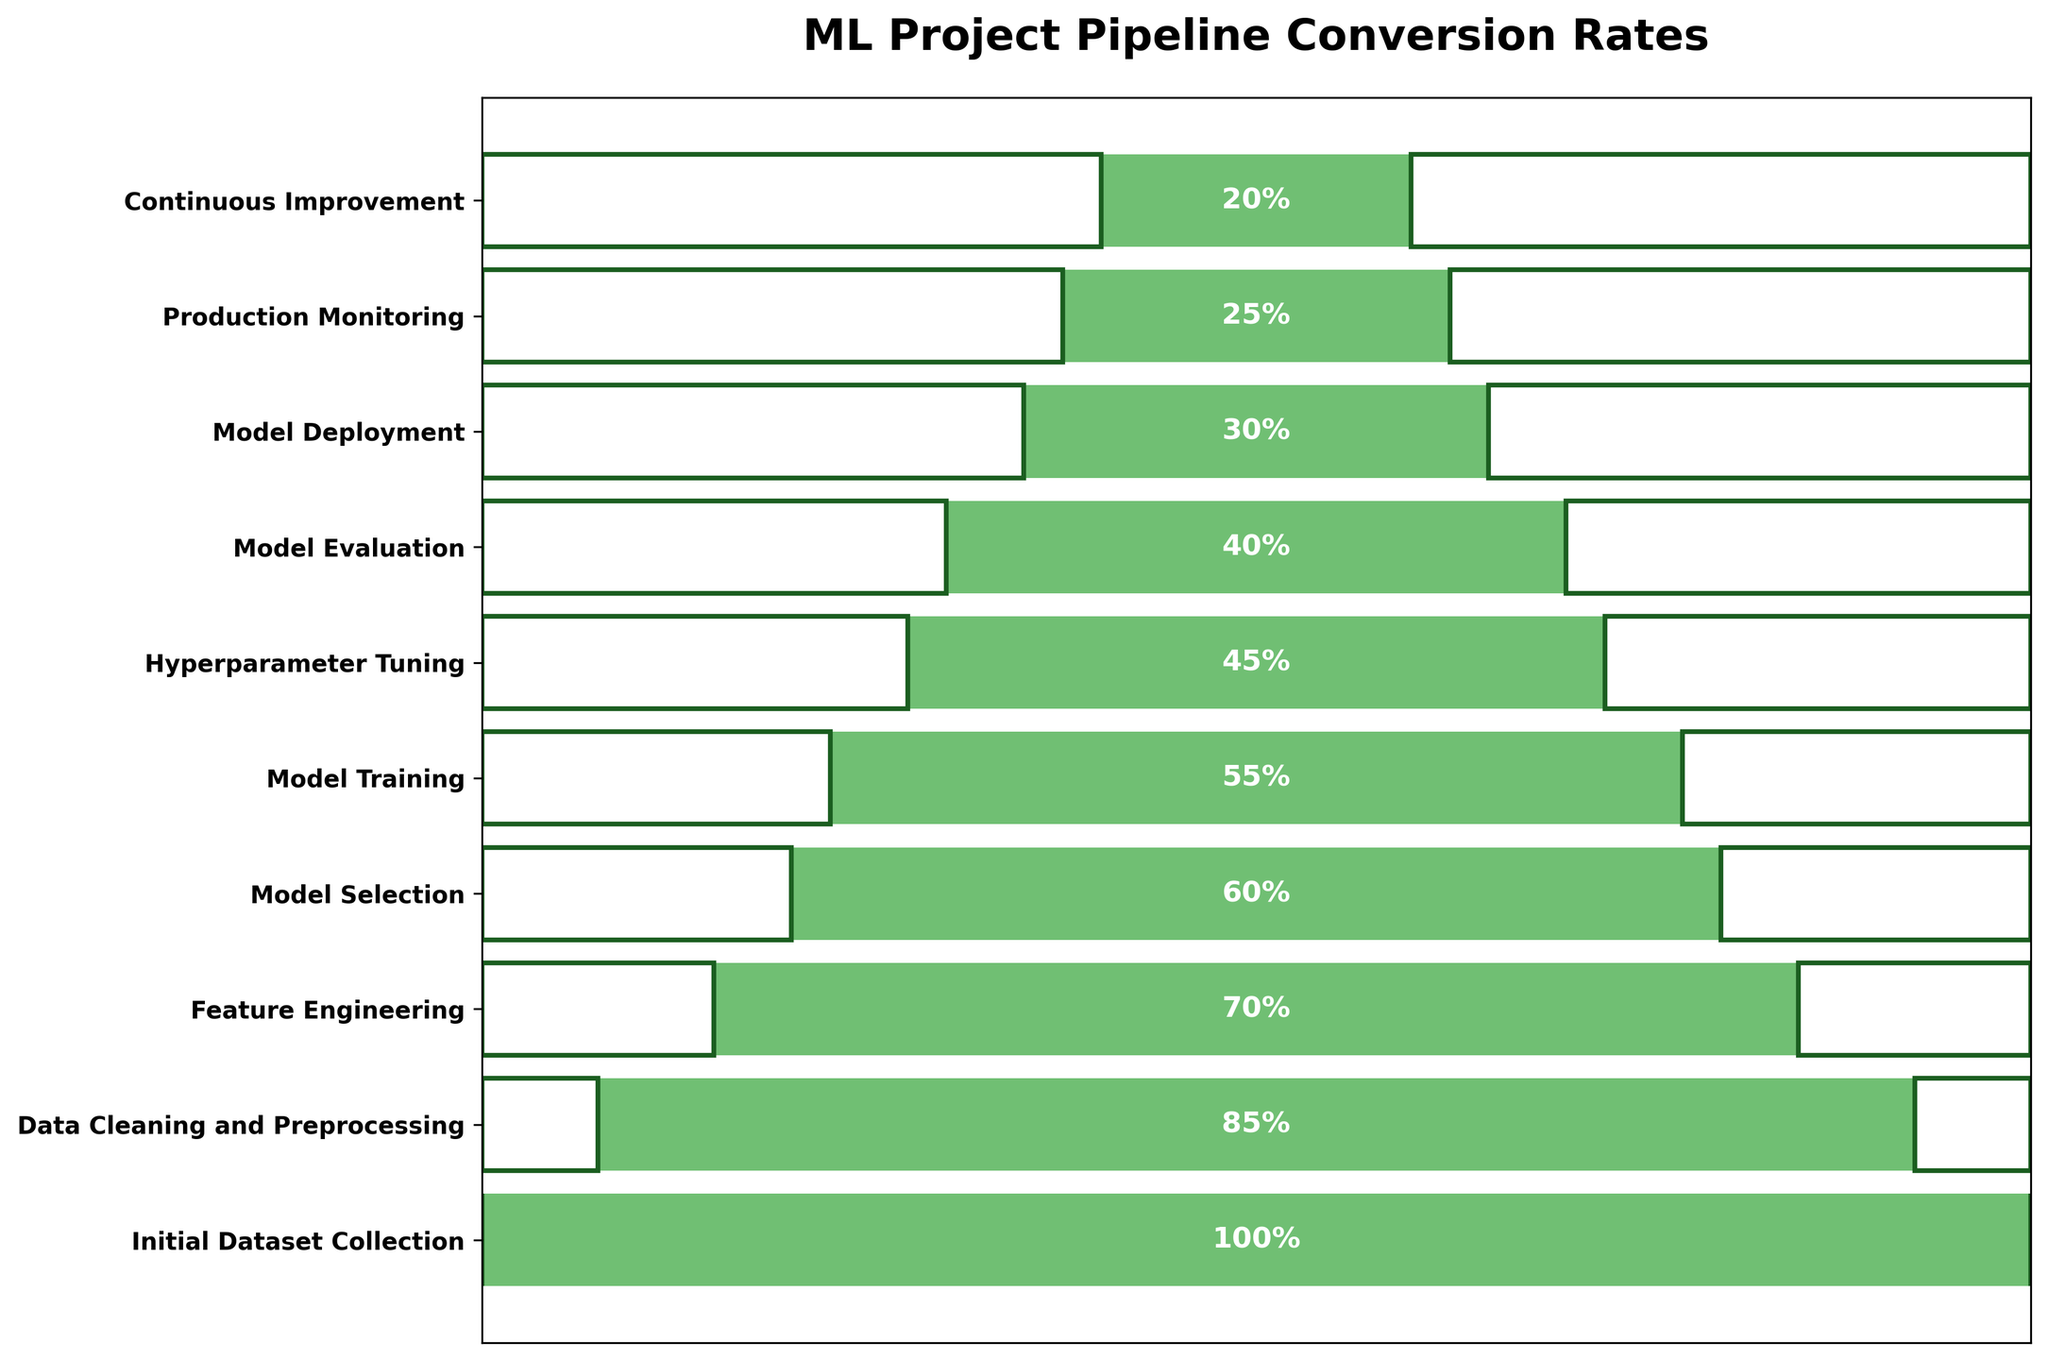What's the title of the funnel chart? The title is displayed at the top of the chart and summarizes what the chart represents.
Answer: ML Project Pipeline Conversion Rates How many stages are there in the pipeline? The number of horizontal bars (stages) represents the different stages in the pipeline. By counting these bars, we can determine there are 10 stages.
Answer: 10 Which stage has the highest conversion percentage? The highest conversion percentage corresponds to the longest bar, located at the top and representing the first stage.
Answer: Initial Dataset Collection What is the conversion rate difference between "Initial Dataset Collection" and "Production Monitoring"? We can find the difference by subtracting the conversion rates of both stages. Initial Dataset Collection is 100% and Production Monitoring is 25%. 100% - 25% = 75%
Answer: 75% How much greater is the conversion rate at "Data Cleaning and Preprocessing" compared to "Model Evaluation"? By subtracting the percentage of Model Evaluation from Data Cleaning and Preprocessing: 85% - 40% = 45%
Answer: 45% Calculate the average conversion rate across all stages. Sum all the conversion rates (100 + 85 + 70 + 60 + 55 + 45 + 40 + 30 + 25 + 20) and divide by the number of stages (10). Total sum is 530. Average is 530 / 10 = 53%
Answer: 53% Compare the drop in conversion rate from "Model Training" to "Hyperparameter Tuning" with the drop from "Model Deployment" to "Production Monitoring". The drop from Model Training (55%) to Hyperparameter Tuning (45%) is 10%. The drop from Model Deployment (30%) to Production Monitoring (25%) is 5%.
Answer: 10% vs 5% Where does "Feature Engineering" rank in terms of conversion rates among all stages? Feature Engineering has a conversion rate of 70%, which puts it third highest when converting rates are sorted downward from largest to smallest.
Answer: Third Identify the stage with the smallest percentage of conversions. The smallest percentage of conversions is at the bottom of the chart. The stage here is Continuous Improvement with 20%.
Answer: Continuous Improvement What is the cumulative drop in conversion rates from "Initial Dataset Collection" to "Continuous Improvement"? By calculating the total percentage drop: 100% (Initial Dataset Collection) to 20% (Continuous Improvement), the cumulative drop is 100% - 20% = 80%
Answer: 80% 